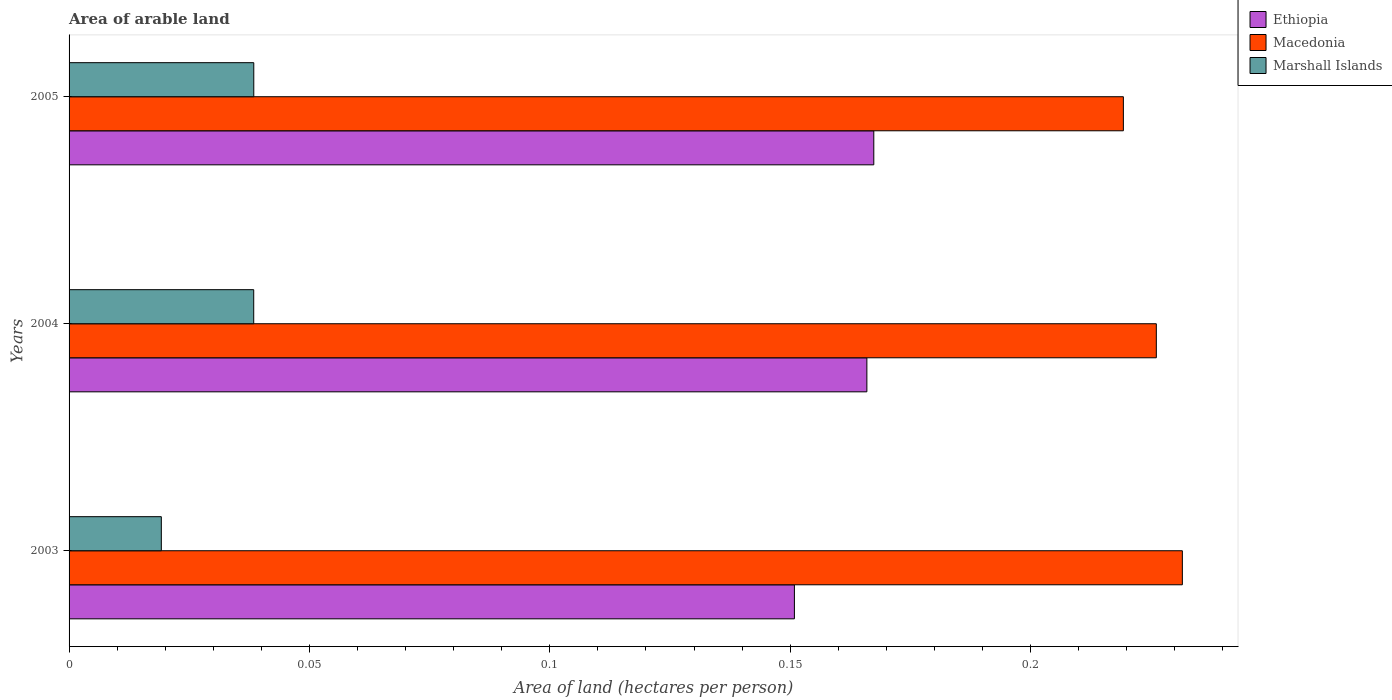How many groups of bars are there?
Your answer should be very brief. 3. Are the number of bars per tick equal to the number of legend labels?
Provide a succinct answer. Yes. Are the number of bars on each tick of the Y-axis equal?
Offer a terse response. Yes. How many bars are there on the 3rd tick from the top?
Offer a very short reply. 3. What is the total arable land in Ethiopia in 2005?
Provide a succinct answer. 0.17. Across all years, what is the maximum total arable land in Marshall Islands?
Keep it short and to the point. 0.04. Across all years, what is the minimum total arable land in Ethiopia?
Your answer should be compact. 0.15. In which year was the total arable land in Ethiopia maximum?
Your response must be concise. 2005. In which year was the total arable land in Macedonia minimum?
Make the answer very short. 2005. What is the total total arable land in Marshall Islands in the graph?
Your answer should be very brief. 0.1. What is the difference between the total arable land in Macedonia in 2003 and that in 2005?
Provide a short and direct response. 0.01. What is the difference between the total arable land in Macedonia in 2004 and the total arable land in Marshall Islands in 2005?
Your answer should be very brief. 0.19. What is the average total arable land in Marshall Islands per year?
Provide a succinct answer. 0.03. In the year 2003, what is the difference between the total arable land in Marshall Islands and total arable land in Ethiopia?
Provide a succinct answer. -0.13. In how many years, is the total arable land in Marshall Islands greater than 0.02 hectares per person?
Your answer should be very brief. 2. What is the ratio of the total arable land in Macedonia in 2004 to that in 2005?
Keep it short and to the point. 1.03. Is the difference between the total arable land in Marshall Islands in 2003 and 2004 greater than the difference between the total arable land in Ethiopia in 2003 and 2004?
Offer a very short reply. No. What is the difference between the highest and the second highest total arable land in Macedonia?
Your answer should be compact. 0.01. What is the difference between the highest and the lowest total arable land in Macedonia?
Your answer should be compact. 0.01. Is the sum of the total arable land in Macedonia in 2003 and 2004 greater than the maximum total arable land in Marshall Islands across all years?
Your answer should be compact. Yes. What does the 3rd bar from the top in 2003 represents?
Keep it short and to the point. Ethiopia. What does the 1st bar from the bottom in 2005 represents?
Make the answer very short. Ethiopia. Is it the case that in every year, the sum of the total arable land in Marshall Islands and total arable land in Macedonia is greater than the total arable land in Ethiopia?
Offer a terse response. Yes. How many years are there in the graph?
Provide a succinct answer. 3. Are the values on the major ticks of X-axis written in scientific E-notation?
Provide a short and direct response. No. Does the graph contain grids?
Offer a terse response. No. Where does the legend appear in the graph?
Your answer should be very brief. Top right. How many legend labels are there?
Your answer should be compact. 3. How are the legend labels stacked?
Ensure brevity in your answer.  Vertical. What is the title of the graph?
Ensure brevity in your answer.  Area of arable land. Does "Kiribati" appear as one of the legend labels in the graph?
Ensure brevity in your answer.  No. What is the label or title of the X-axis?
Offer a very short reply. Area of land (hectares per person). What is the Area of land (hectares per person) of Ethiopia in 2003?
Provide a short and direct response. 0.15. What is the Area of land (hectares per person) of Macedonia in 2003?
Provide a succinct answer. 0.23. What is the Area of land (hectares per person) of Marshall Islands in 2003?
Ensure brevity in your answer.  0.02. What is the Area of land (hectares per person) in Ethiopia in 2004?
Offer a terse response. 0.17. What is the Area of land (hectares per person) in Macedonia in 2004?
Provide a short and direct response. 0.23. What is the Area of land (hectares per person) in Marshall Islands in 2004?
Your response must be concise. 0.04. What is the Area of land (hectares per person) in Ethiopia in 2005?
Your answer should be compact. 0.17. What is the Area of land (hectares per person) of Macedonia in 2005?
Your answer should be very brief. 0.22. What is the Area of land (hectares per person) in Marshall Islands in 2005?
Your response must be concise. 0.04. Across all years, what is the maximum Area of land (hectares per person) of Ethiopia?
Your answer should be very brief. 0.17. Across all years, what is the maximum Area of land (hectares per person) of Macedonia?
Offer a very short reply. 0.23. Across all years, what is the maximum Area of land (hectares per person) in Marshall Islands?
Your answer should be very brief. 0.04. Across all years, what is the minimum Area of land (hectares per person) in Ethiopia?
Ensure brevity in your answer.  0.15. Across all years, what is the minimum Area of land (hectares per person) in Macedonia?
Offer a terse response. 0.22. Across all years, what is the minimum Area of land (hectares per person) of Marshall Islands?
Keep it short and to the point. 0.02. What is the total Area of land (hectares per person) of Ethiopia in the graph?
Keep it short and to the point. 0.48. What is the total Area of land (hectares per person) in Macedonia in the graph?
Offer a terse response. 0.68. What is the total Area of land (hectares per person) in Marshall Islands in the graph?
Offer a terse response. 0.1. What is the difference between the Area of land (hectares per person) in Ethiopia in 2003 and that in 2004?
Give a very brief answer. -0.02. What is the difference between the Area of land (hectares per person) of Macedonia in 2003 and that in 2004?
Your answer should be compact. 0.01. What is the difference between the Area of land (hectares per person) of Marshall Islands in 2003 and that in 2004?
Make the answer very short. -0.02. What is the difference between the Area of land (hectares per person) of Ethiopia in 2003 and that in 2005?
Provide a short and direct response. -0.02. What is the difference between the Area of land (hectares per person) of Macedonia in 2003 and that in 2005?
Your response must be concise. 0.01. What is the difference between the Area of land (hectares per person) of Marshall Islands in 2003 and that in 2005?
Your response must be concise. -0.02. What is the difference between the Area of land (hectares per person) of Ethiopia in 2004 and that in 2005?
Offer a terse response. -0. What is the difference between the Area of land (hectares per person) of Macedonia in 2004 and that in 2005?
Offer a very short reply. 0.01. What is the difference between the Area of land (hectares per person) of Ethiopia in 2003 and the Area of land (hectares per person) of Macedonia in 2004?
Keep it short and to the point. -0.08. What is the difference between the Area of land (hectares per person) in Ethiopia in 2003 and the Area of land (hectares per person) in Marshall Islands in 2004?
Give a very brief answer. 0.11. What is the difference between the Area of land (hectares per person) in Macedonia in 2003 and the Area of land (hectares per person) in Marshall Islands in 2004?
Offer a terse response. 0.19. What is the difference between the Area of land (hectares per person) of Ethiopia in 2003 and the Area of land (hectares per person) of Macedonia in 2005?
Give a very brief answer. -0.07. What is the difference between the Area of land (hectares per person) in Ethiopia in 2003 and the Area of land (hectares per person) in Marshall Islands in 2005?
Provide a short and direct response. 0.11. What is the difference between the Area of land (hectares per person) of Macedonia in 2003 and the Area of land (hectares per person) of Marshall Islands in 2005?
Make the answer very short. 0.19. What is the difference between the Area of land (hectares per person) in Ethiopia in 2004 and the Area of land (hectares per person) in Macedonia in 2005?
Offer a terse response. -0.05. What is the difference between the Area of land (hectares per person) of Ethiopia in 2004 and the Area of land (hectares per person) of Marshall Islands in 2005?
Your response must be concise. 0.13. What is the difference between the Area of land (hectares per person) in Macedonia in 2004 and the Area of land (hectares per person) in Marshall Islands in 2005?
Provide a short and direct response. 0.19. What is the average Area of land (hectares per person) in Ethiopia per year?
Give a very brief answer. 0.16. What is the average Area of land (hectares per person) of Macedonia per year?
Your answer should be very brief. 0.23. What is the average Area of land (hectares per person) of Marshall Islands per year?
Provide a succinct answer. 0.03. In the year 2003, what is the difference between the Area of land (hectares per person) in Ethiopia and Area of land (hectares per person) in Macedonia?
Ensure brevity in your answer.  -0.08. In the year 2003, what is the difference between the Area of land (hectares per person) in Ethiopia and Area of land (hectares per person) in Marshall Islands?
Your answer should be very brief. 0.13. In the year 2003, what is the difference between the Area of land (hectares per person) in Macedonia and Area of land (hectares per person) in Marshall Islands?
Your answer should be compact. 0.21. In the year 2004, what is the difference between the Area of land (hectares per person) of Ethiopia and Area of land (hectares per person) of Macedonia?
Give a very brief answer. -0.06. In the year 2004, what is the difference between the Area of land (hectares per person) of Ethiopia and Area of land (hectares per person) of Marshall Islands?
Give a very brief answer. 0.13. In the year 2004, what is the difference between the Area of land (hectares per person) of Macedonia and Area of land (hectares per person) of Marshall Islands?
Your answer should be compact. 0.19. In the year 2005, what is the difference between the Area of land (hectares per person) in Ethiopia and Area of land (hectares per person) in Macedonia?
Your answer should be compact. -0.05. In the year 2005, what is the difference between the Area of land (hectares per person) in Ethiopia and Area of land (hectares per person) in Marshall Islands?
Provide a short and direct response. 0.13. In the year 2005, what is the difference between the Area of land (hectares per person) of Macedonia and Area of land (hectares per person) of Marshall Islands?
Provide a succinct answer. 0.18. What is the ratio of the Area of land (hectares per person) of Ethiopia in 2003 to that in 2004?
Keep it short and to the point. 0.91. What is the ratio of the Area of land (hectares per person) in Macedonia in 2003 to that in 2004?
Offer a terse response. 1.02. What is the ratio of the Area of land (hectares per person) in Marshall Islands in 2003 to that in 2004?
Keep it short and to the point. 0.5. What is the ratio of the Area of land (hectares per person) of Ethiopia in 2003 to that in 2005?
Give a very brief answer. 0.9. What is the ratio of the Area of land (hectares per person) in Macedonia in 2003 to that in 2005?
Provide a short and direct response. 1.06. What is the ratio of the Area of land (hectares per person) in Marshall Islands in 2003 to that in 2005?
Make the answer very short. 0.5. What is the ratio of the Area of land (hectares per person) in Ethiopia in 2004 to that in 2005?
Offer a very short reply. 0.99. What is the ratio of the Area of land (hectares per person) in Macedonia in 2004 to that in 2005?
Offer a very short reply. 1.03. What is the ratio of the Area of land (hectares per person) of Marshall Islands in 2004 to that in 2005?
Give a very brief answer. 1. What is the difference between the highest and the second highest Area of land (hectares per person) in Ethiopia?
Your response must be concise. 0. What is the difference between the highest and the second highest Area of land (hectares per person) of Macedonia?
Offer a terse response. 0.01. What is the difference between the highest and the lowest Area of land (hectares per person) of Ethiopia?
Give a very brief answer. 0.02. What is the difference between the highest and the lowest Area of land (hectares per person) in Macedonia?
Offer a very short reply. 0.01. What is the difference between the highest and the lowest Area of land (hectares per person) of Marshall Islands?
Give a very brief answer. 0.02. 